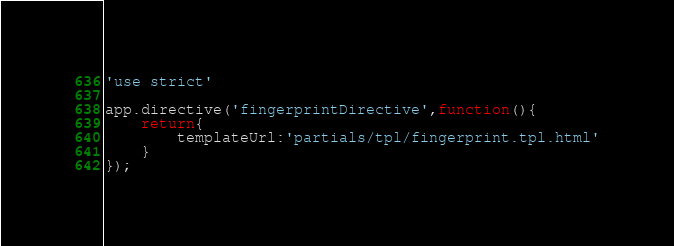<code> <loc_0><loc_0><loc_500><loc_500><_JavaScript_>'use strict'

app.directive('fingerprintDirective',function(){
	return{
		templateUrl:'partials/tpl/fingerprint.tpl.html'
	}
});</code> 